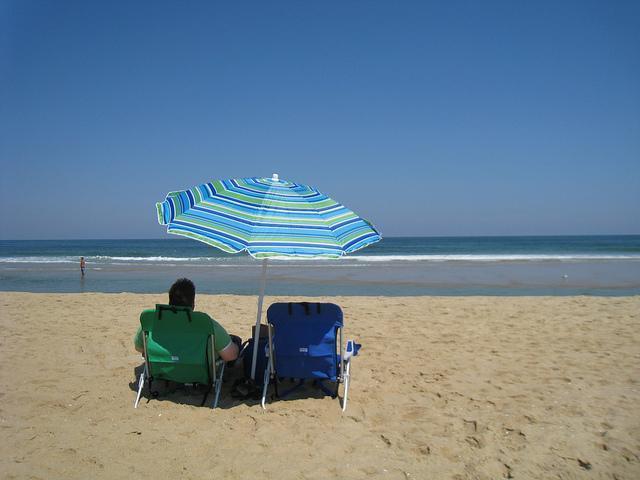How many people are on the beach?
Give a very brief answer. 2. How many chairs are in the photo?
Give a very brief answer. 2. How many people are holding a remote controller?
Give a very brief answer. 0. 